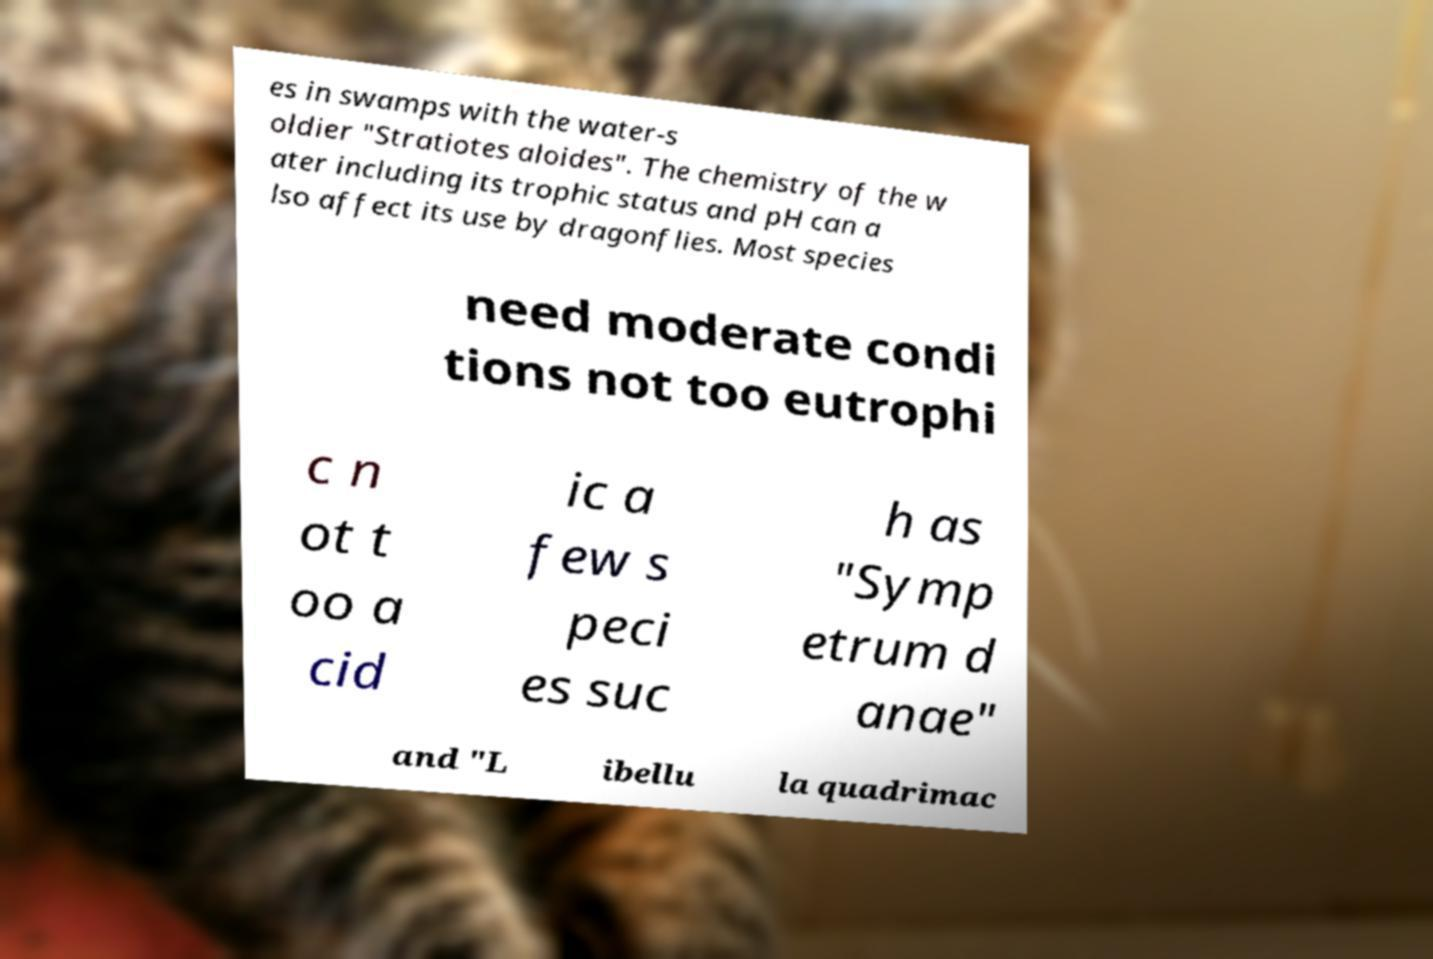Could you extract and type out the text from this image? es in swamps with the water-s oldier "Stratiotes aloides". The chemistry of the w ater including its trophic status and pH can a lso affect its use by dragonflies. Most species need moderate condi tions not too eutrophi c n ot t oo a cid ic a few s peci es suc h as "Symp etrum d anae" and "L ibellu la quadrimac 